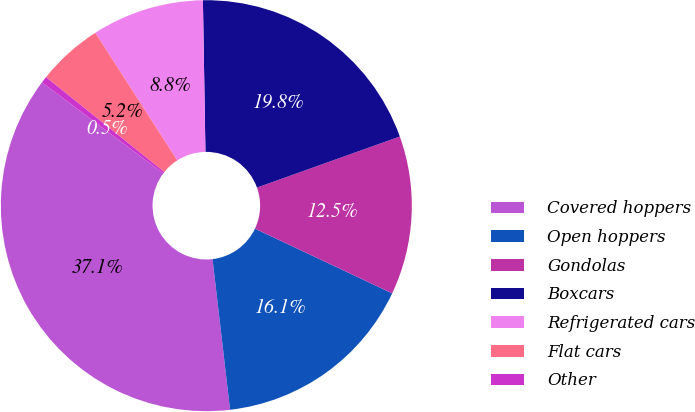Convert chart to OTSL. <chart><loc_0><loc_0><loc_500><loc_500><pie_chart><fcel>Covered hoppers<fcel>Open hoppers<fcel>Gondolas<fcel>Boxcars<fcel>Refrigerated cars<fcel>Flat cars<fcel>Other<nl><fcel>37.09%<fcel>16.14%<fcel>12.48%<fcel>19.8%<fcel>8.82%<fcel>5.16%<fcel>0.51%<nl></chart> 